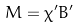<formula> <loc_0><loc_0><loc_500><loc_500>M = \chi ^ { \prime } B ^ { \prime }</formula> 